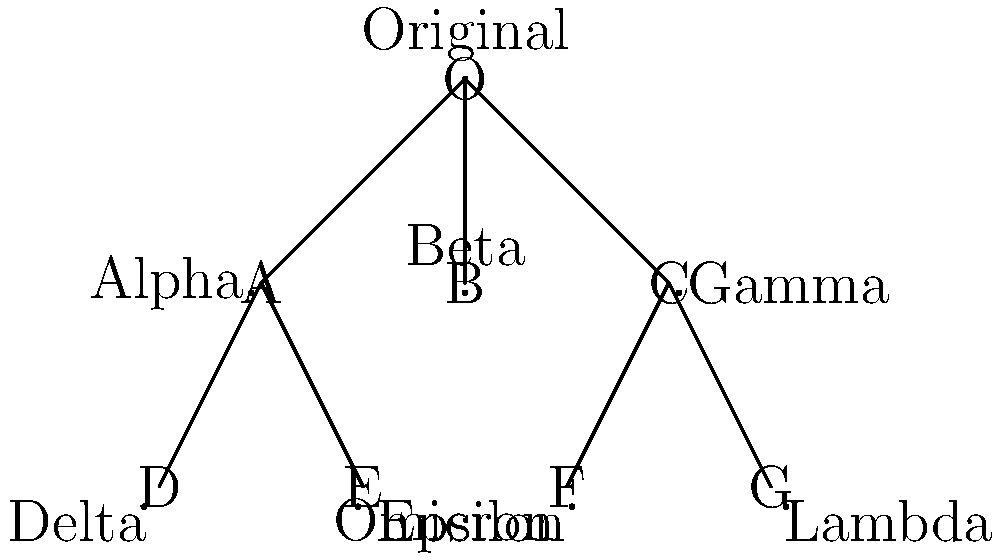As a community leader, you're analyzing the spread of COVID-19 variants in your local population. The tree diagram above represents the evolution of variants, where each node represents a variant and edges show the direct evolution from one variant to another. How many variants in this diagram evolved directly from the original strain? To solve this problem, we need to follow these steps:

1. Identify the node representing the original strain:
   The root node "O" at the top of the tree represents the original strain.

2. Count the number of edges directly connected to the original strain:
   - There is an edge connecting "O" to "A" (Alpha variant)
   - There is an edge connecting "O" to "B" (Beta variant)
   - There is an edge connecting "O" to "C" (Gamma variant)

3. Sum up the total number of direct connections:
   There are 3 edges directly connected to the original strain.

Therefore, 3 variants (Alpha, Beta, and Gamma) evolved directly from the original strain in this diagram.

This information is crucial for understanding the initial diversification of the virus and can help in developing strategies to monitor and respond to the spread of these primary variants in the community.
Answer: 3 